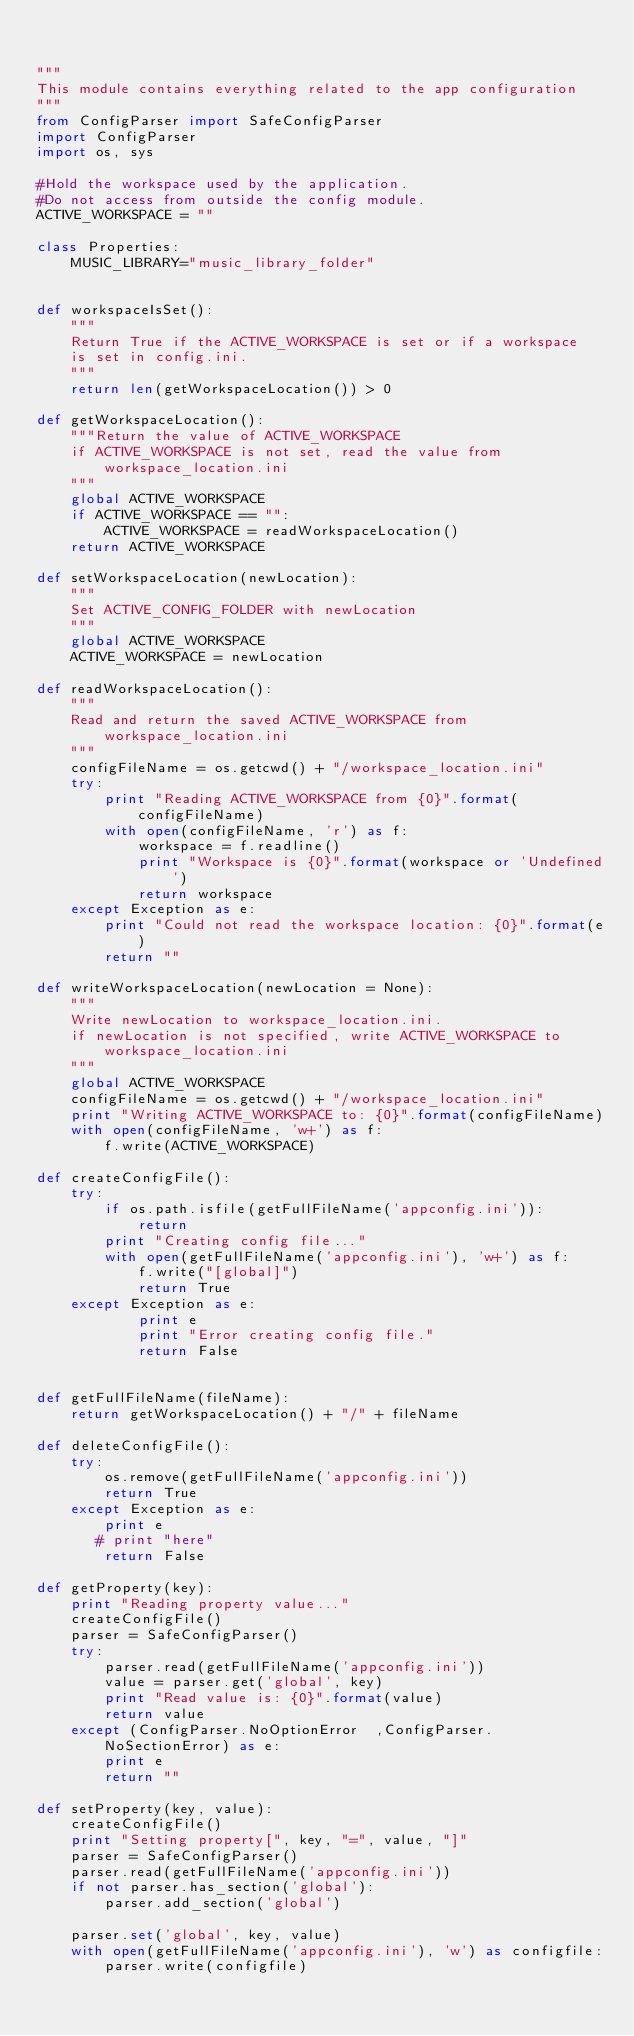Convert code to text. <code><loc_0><loc_0><loc_500><loc_500><_Python_>

"""
This module contains everything related to the app configuration
"""
from ConfigParser import SafeConfigParser
import ConfigParser
import os, sys

#Hold the workspace used by the application.
#Do not access from outside the config module.
ACTIVE_WORKSPACE = ""

class Properties:
    MUSIC_LIBRARY="music_library_folder"


def workspaceIsSet():
    """
    Return True if the ACTIVE_WORKSPACE is set or if a workspace
    is set in config.ini.
    """
    return len(getWorkspaceLocation()) > 0

def getWorkspaceLocation():
    """Return the value of ACTIVE_WORKSPACE
    if ACTIVE_WORKSPACE is not set, read the value from workspace_location.ini
    """
    global ACTIVE_WORKSPACE
    if ACTIVE_WORKSPACE == "":
        ACTIVE_WORKSPACE = readWorkspaceLocation()
    return ACTIVE_WORKSPACE

def setWorkspaceLocation(newLocation):
    """
    Set ACTIVE_CONFIG_FOLDER with newLocation
    """
    global ACTIVE_WORKSPACE
    ACTIVE_WORKSPACE = newLocation

def readWorkspaceLocation():
    """
    Read and return the saved ACTIVE_WORKSPACE from workspace_location.ini
    """
    configFileName = os.getcwd() + "/workspace_location.ini"
    try:
        print "Reading ACTIVE_WORKSPACE from {0}".format(configFileName)
        with open(configFileName, 'r') as f:
            workspace = f.readline()
            print "Workspace is {0}".format(workspace or 'Undefined')
            return workspace
    except Exception as e:
        print "Could not read the workspace location: {0}".format(e)
        return ""

def writeWorkspaceLocation(newLocation = None):
    """
    Write newLocation to workspace_location.ini.
    if newLocation is not specified, write ACTIVE_WORKSPACE to workspace_location.ini
    """
    global ACTIVE_WORKSPACE
    configFileName = os.getcwd() + "/workspace_location.ini"
    print "Writing ACTIVE_WORKSPACE to: {0}".format(configFileName)
    with open(configFileName, 'w+') as f:
        f.write(ACTIVE_WORKSPACE)

def createConfigFile():
    try:
        if os.path.isfile(getFullFileName('appconfig.ini')):
            return
        print "Creating config file..."
        with open(getFullFileName('appconfig.ini'), 'w+') as f:
            f.write("[global]")
            return True
    except Exception as e:
            print e
            print "Error creating config file."
            return False


def getFullFileName(fileName):
    return getWorkspaceLocation() + "/" + fileName

def deleteConfigFile():
    try:
        os.remove(getFullFileName('appconfig.ini'))
        return True
    except Exception as e:
        print e
       # print "here"
        return False

def getProperty(key):
    print "Reading property value..."
    createConfigFile()
    parser = SafeConfigParser()
    try:
        parser.read(getFullFileName('appconfig.ini'))
        value = parser.get('global', key)
        print "Read value is: {0}".format(value)
        return value
    except (ConfigParser.NoOptionError  ,ConfigParser.NoSectionError) as e:
        print e
        return ""

def setProperty(key, value):
    createConfigFile()
    print "Setting property[", key, "=", value, "]"
    parser = SafeConfigParser()
    parser.read(getFullFileName('appconfig.ini'))
    if not parser.has_section('global'):
        parser.add_section('global')

    parser.set('global', key, value)
    with open(getFullFileName('appconfig.ini'), 'w') as configfile:
        parser.write(configfile)</code> 